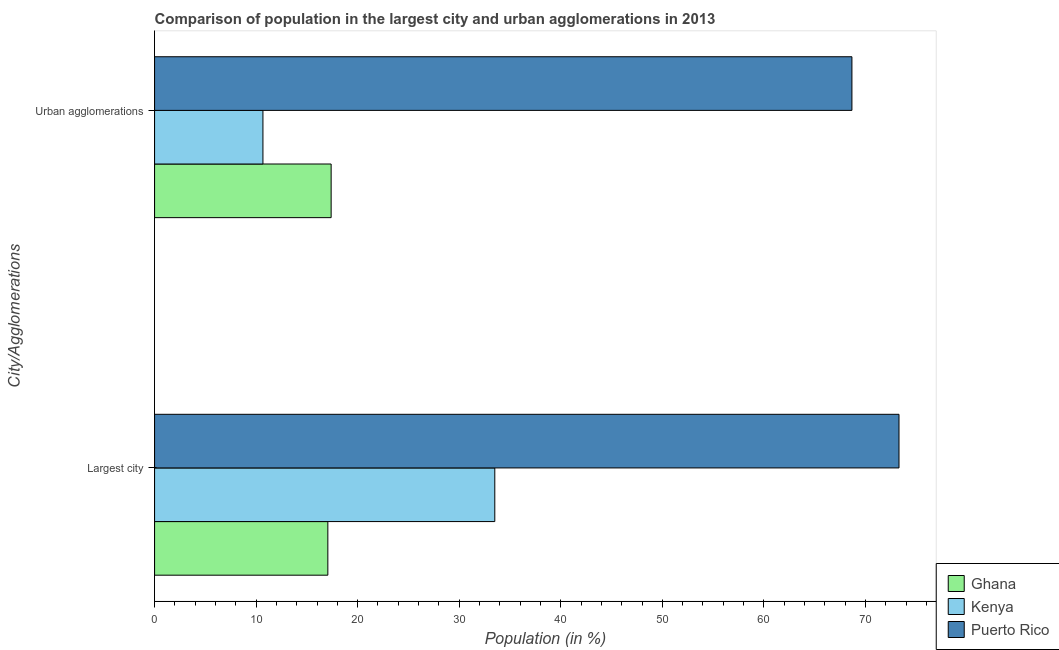How many different coloured bars are there?
Make the answer very short. 3. How many groups of bars are there?
Offer a terse response. 2. Are the number of bars on each tick of the Y-axis equal?
Make the answer very short. Yes. What is the label of the 1st group of bars from the top?
Your response must be concise. Urban agglomerations. What is the population in the largest city in Kenya?
Offer a terse response. 33.5. Across all countries, what is the maximum population in urban agglomerations?
Make the answer very short. 68.67. Across all countries, what is the minimum population in the largest city?
Ensure brevity in your answer.  17.06. In which country was the population in urban agglomerations maximum?
Provide a short and direct response. Puerto Rico. What is the total population in the largest city in the graph?
Keep it short and to the point. 123.87. What is the difference between the population in urban agglomerations in Kenya and that in Puerto Rico?
Make the answer very short. -58. What is the difference between the population in urban agglomerations in Ghana and the population in the largest city in Kenya?
Provide a succinct answer. -16.12. What is the average population in the largest city per country?
Provide a succinct answer. 41.29. What is the difference between the population in the largest city and population in urban agglomerations in Kenya?
Provide a succinct answer. 22.83. What is the ratio of the population in the largest city in Kenya to that in Puerto Rico?
Your answer should be very brief. 0.46. Is the population in urban agglomerations in Kenya less than that in Ghana?
Make the answer very short. Yes. What does the 1st bar from the top in Urban agglomerations represents?
Your answer should be compact. Puerto Rico. What does the 3rd bar from the bottom in Urban agglomerations represents?
Offer a very short reply. Puerto Rico. How many bars are there?
Your answer should be compact. 6. Are all the bars in the graph horizontal?
Provide a short and direct response. Yes. What is the difference between two consecutive major ticks on the X-axis?
Keep it short and to the point. 10. Does the graph contain any zero values?
Your answer should be compact. No. What is the title of the graph?
Provide a short and direct response. Comparison of population in the largest city and urban agglomerations in 2013. What is the label or title of the X-axis?
Keep it short and to the point. Population (in %). What is the label or title of the Y-axis?
Offer a terse response. City/Agglomerations. What is the Population (in %) in Ghana in Largest city?
Your answer should be compact. 17.06. What is the Population (in %) in Kenya in Largest city?
Your answer should be very brief. 33.5. What is the Population (in %) in Puerto Rico in Largest city?
Provide a short and direct response. 73.3. What is the Population (in %) of Ghana in Urban agglomerations?
Offer a terse response. 17.39. What is the Population (in %) of Kenya in Urban agglomerations?
Your response must be concise. 10.67. What is the Population (in %) of Puerto Rico in Urban agglomerations?
Make the answer very short. 68.67. Across all City/Agglomerations, what is the maximum Population (in %) of Ghana?
Give a very brief answer. 17.39. Across all City/Agglomerations, what is the maximum Population (in %) of Kenya?
Offer a terse response. 33.5. Across all City/Agglomerations, what is the maximum Population (in %) in Puerto Rico?
Provide a short and direct response. 73.3. Across all City/Agglomerations, what is the minimum Population (in %) in Ghana?
Keep it short and to the point. 17.06. Across all City/Agglomerations, what is the minimum Population (in %) in Kenya?
Give a very brief answer. 10.67. Across all City/Agglomerations, what is the minimum Population (in %) of Puerto Rico?
Your answer should be compact. 68.67. What is the total Population (in %) in Ghana in the graph?
Offer a terse response. 34.45. What is the total Population (in %) in Kenya in the graph?
Offer a terse response. 44.17. What is the total Population (in %) in Puerto Rico in the graph?
Offer a terse response. 141.97. What is the difference between the Population (in %) in Ghana in Largest city and that in Urban agglomerations?
Your answer should be compact. -0.32. What is the difference between the Population (in %) of Kenya in Largest city and that in Urban agglomerations?
Keep it short and to the point. 22.83. What is the difference between the Population (in %) in Puerto Rico in Largest city and that in Urban agglomerations?
Your answer should be very brief. 4.64. What is the difference between the Population (in %) of Ghana in Largest city and the Population (in %) of Kenya in Urban agglomerations?
Your answer should be compact. 6.39. What is the difference between the Population (in %) in Ghana in Largest city and the Population (in %) in Puerto Rico in Urban agglomerations?
Provide a short and direct response. -51.61. What is the difference between the Population (in %) in Kenya in Largest city and the Population (in %) in Puerto Rico in Urban agglomerations?
Offer a terse response. -35.17. What is the average Population (in %) of Ghana per City/Agglomerations?
Make the answer very short. 17.22. What is the average Population (in %) in Kenya per City/Agglomerations?
Offer a terse response. 22.09. What is the average Population (in %) in Puerto Rico per City/Agglomerations?
Provide a succinct answer. 70.99. What is the difference between the Population (in %) of Ghana and Population (in %) of Kenya in Largest city?
Your answer should be very brief. -16.44. What is the difference between the Population (in %) in Ghana and Population (in %) in Puerto Rico in Largest city?
Make the answer very short. -56.24. What is the difference between the Population (in %) of Kenya and Population (in %) of Puerto Rico in Largest city?
Offer a terse response. -39.8. What is the difference between the Population (in %) in Ghana and Population (in %) in Kenya in Urban agglomerations?
Offer a very short reply. 6.72. What is the difference between the Population (in %) in Ghana and Population (in %) in Puerto Rico in Urban agglomerations?
Provide a short and direct response. -51.28. What is the difference between the Population (in %) in Kenya and Population (in %) in Puerto Rico in Urban agglomerations?
Offer a terse response. -58. What is the ratio of the Population (in %) in Ghana in Largest city to that in Urban agglomerations?
Provide a short and direct response. 0.98. What is the ratio of the Population (in %) in Kenya in Largest city to that in Urban agglomerations?
Your response must be concise. 3.14. What is the ratio of the Population (in %) in Puerto Rico in Largest city to that in Urban agglomerations?
Keep it short and to the point. 1.07. What is the difference between the highest and the second highest Population (in %) in Ghana?
Your answer should be compact. 0.32. What is the difference between the highest and the second highest Population (in %) in Kenya?
Provide a short and direct response. 22.83. What is the difference between the highest and the second highest Population (in %) of Puerto Rico?
Keep it short and to the point. 4.64. What is the difference between the highest and the lowest Population (in %) of Ghana?
Provide a succinct answer. 0.32. What is the difference between the highest and the lowest Population (in %) of Kenya?
Provide a short and direct response. 22.83. What is the difference between the highest and the lowest Population (in %) in Puerto Rico?
Give a very brief answer. 4.64. 